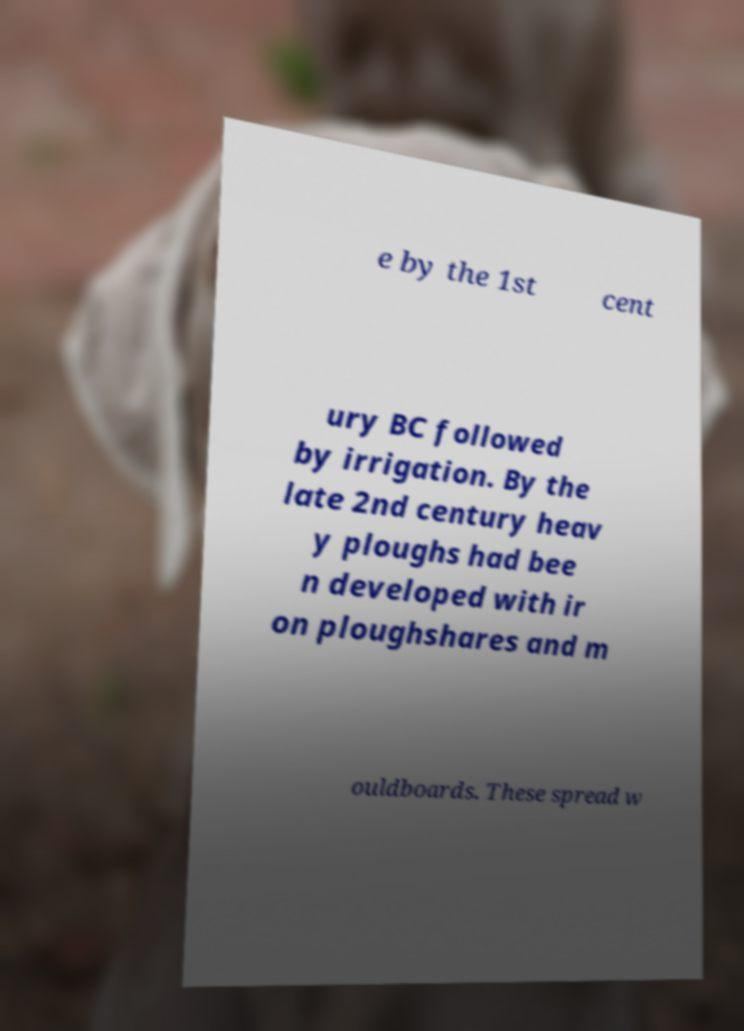Please read and relay the text visible in this image. What does it say? e by the 1st cent ury BC followed by irrigation. By the late 2nd century heav y ploughs had bee n developed with ir on ploughshares and m ouldboards. These spread w 